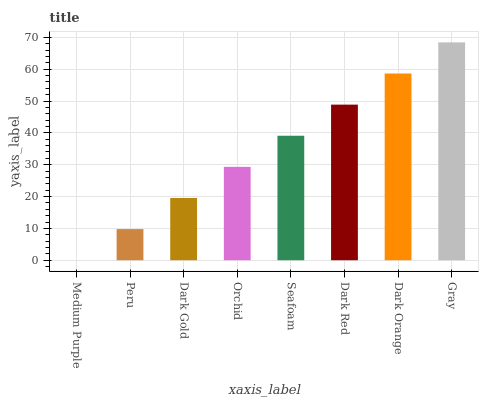Is Medium Purple the minimum?
Answer yes or no. Yes. Is Gray the maximum?
Answer yes or no. Yes. Is Peru the minimum?
Answer yes or no. No. Is Peru the maximum?
Answer yes or no. No. Is Peru greater than Medium Purple?
Answer yes or no. Yes. Is Medium Purple less than Peru?
Answer yes or no. Yes. Is Medium Purple greater than Peru?
Answer yes or no. No. Is Peru less than Medium Purple?
Answer yes or no. No. Is Seafoam the high median?
Answer yes or no. Yes. Is Orchid the low median?
Answer yes or no. Yes. Is Dark Orange the high median?
Answer yes or no. No. Is Seafoam the low median?
Answer yes or no. No. 